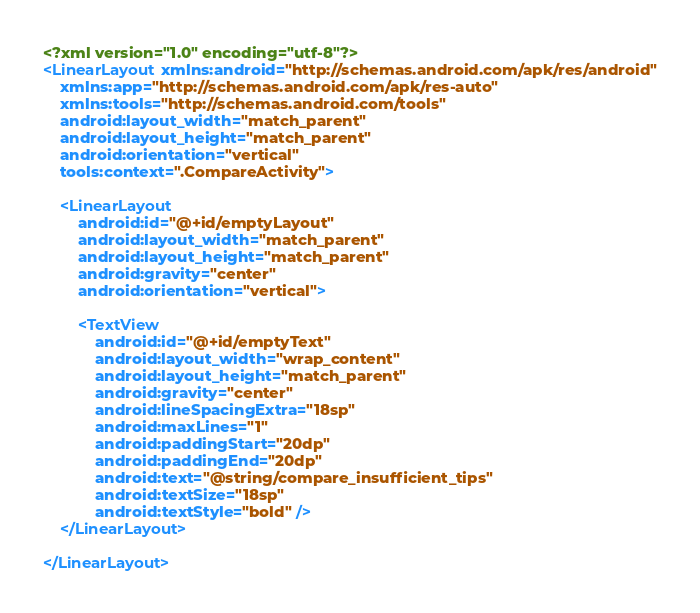Convert code to text. <code><loc_0><loc_0><loc_500><loc_500><_XML_><?xml version="1.0" encoding="utf-8"?>
<LinearLayout xmlns:android="http://schemas.android.com/apk/res/android"
    xmlns:app="http://schemas.android.com/apk/res-auto"
    xmlns:tools="http://schemas.android.com/tools"
    android:layout_width="match_parent"
    android:layout_height="match_parent"
    android:orientation="vertical"
    tools:context=".CompareActivity">

    <LinearLayout
        android:id="@+id/emptyLayout"
        android:layout_width="match_parent"
        android:layout_height="match_parent"
        android:gravity="center"
        android:orientation="vertical">

        <TextView
            android:id="@+id/emptyText"
            android:layout_width="wrap_content"
            android:layout_height="match_parent"
            android:gravity="center"
            android:lineSpacingExtra="18sp"
            android:maxLines="1"
            android:paddingStart="20dp"
            android:paddingEnd="20dp"
            android:text="@string/compare_insufficient_tips"
            android:textSize="18sp"
            android:textStyle="bold" />
    </LinearLayout>

</LinearLayout></code> 